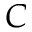<formula> <loc_0><loc_0><loc_500><loc_500>C</formula> 